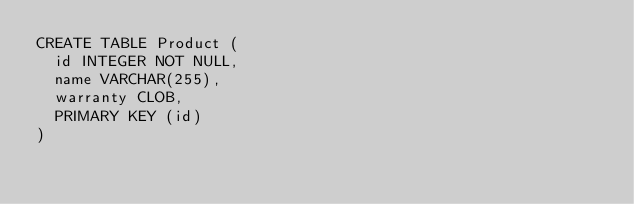<code> <loc_0><loc_0><loc_500><loc_500><_SQL_>CREATE TABLE Product (
  id INTEGER NOT NULL,
  name VARCHAR(255),
  warranty CLOB,
  PRIMARY KEY (id)
)</code> 